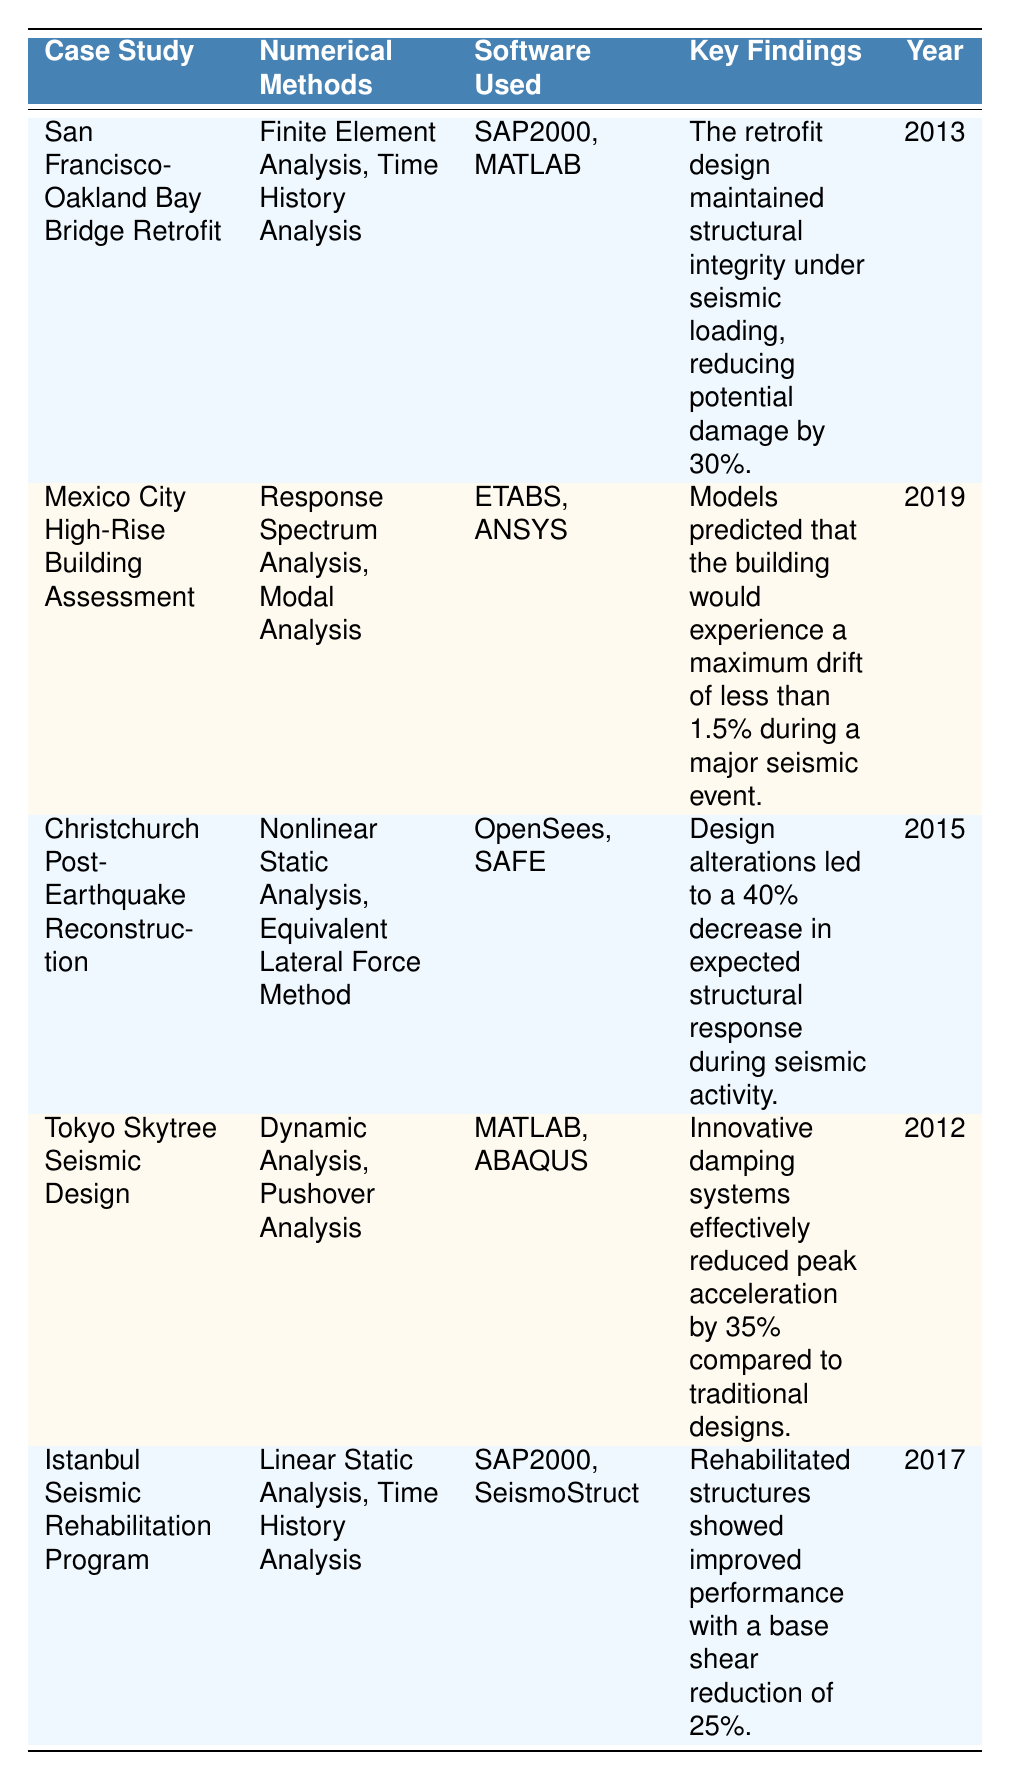What numerical methods were used in the Christchurch Post-Earthquake Reconstruction case study? The Christchurch Post-Earthquake Reconstruction case study lists "Nonlinear Static Analysis" and "Equivalent Lateral Force Method" as the numerical methods used. This information can be found in the second column of the corresponding row.
Answer: Nonlinear Static Analysis, Equivalent Lateral Force Method Which case study used MATLAB as one of the software tools? MATLAB appears in the software used for the San Francisco-Oakland Bay Bridge Retrofit, Tokyo Skytree Seismic Design, and Christchurch Post-Earthquake Reconstruction case studies. Thus, there are three case studies that utilized MATLAB.
Answer: 3 What is the maximum drift predicted for the Mexico City High-Rise Building during a major seismic event? According to the Mexico City High-Rise Building Assessment case study, the maximum drift predicted is less than 1.5%. This detail is stated in the key findings of that specific row.
Answer: Less than 1.5% True or False: The Istanbul Seismic Rehabilitation Program utilized Response Spectrum Analysis as a numerical method. The Istanbul Seismic Rehabilitation Program only lists "Linear Static Analysis" and "Time History Analysis" as its numerical methods, so it did not use Response Spectrum Analysis. Hence, the statement is false.
Answer: False Which case study had the highest percentage reduction in structural response during seismic activity? The Christchurch Post-Earthquake Reconstruction had a 40% decrease in expected structural response, which is the highest compared to the others. By comparing all the percentage reductions in the key findings, it is clear Christchurch had the greatest reduction.
Answer: 40% What year was the Tokyo Skytree Seismic Design conducted? The Tokyo Skytree Seismic Design was conducted in the year 2012, as indicated in the last column of the associated row.
Answer: 2012 What percentage reduction in base shear was achieved in the Istanbul Seismic Rehabilitation Program? The Istanbul Seismic Rehabilitation Program recorded a 25% reduction in base shear, which is explicitly noted in the key findings section of the respective row.
Answer: 25% Which case study had the most recent year of assessment? The Mexico City High-Rise Building Assessment was conducted in the most recent year, 2019, making it the latest among all listed case studies. This can be easily identified by comparing the years in the last column.
Answer: 2019 What software was used in the San Francisco-Oakland Bay Bridge Retrofit case study? The San Francisco-Oakland Bay Bridge Retrofit case study utilized SAP2000 and MATLAB as software tools. This information can be extracted from the third column of the respective row.
Answer: SAP2000, MATLAB 